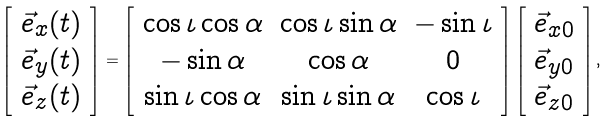Convert formula to latex. <formula><loc_0><loc_0><loc_500><loc_500>\left [ \begin{array} { c } \vec { e } _ { x } ( t ) \\ \vec { e } _ { y } ( t ) \\ \vec { e } _ { z } ( t ) \end{array} \right ] = \left [ \begin{array} { c c c } \cos \iota \cos \alpha & \cos \iota \sin \alpha & - \sin \iota \\ - \sin \alpha & \cos \alpha & 0 \\ \sin \iota \cos \alpha & \sin \iota \sin \alpha & \cos \iota \end{array} \right ] \left [ \begin{array} { c } \vec { e } _ { x 0 } \\ \vec { e } _ { y 0 } \\ \vec { e } _ { z 0 } \end{array} \right ] ,</formula> 